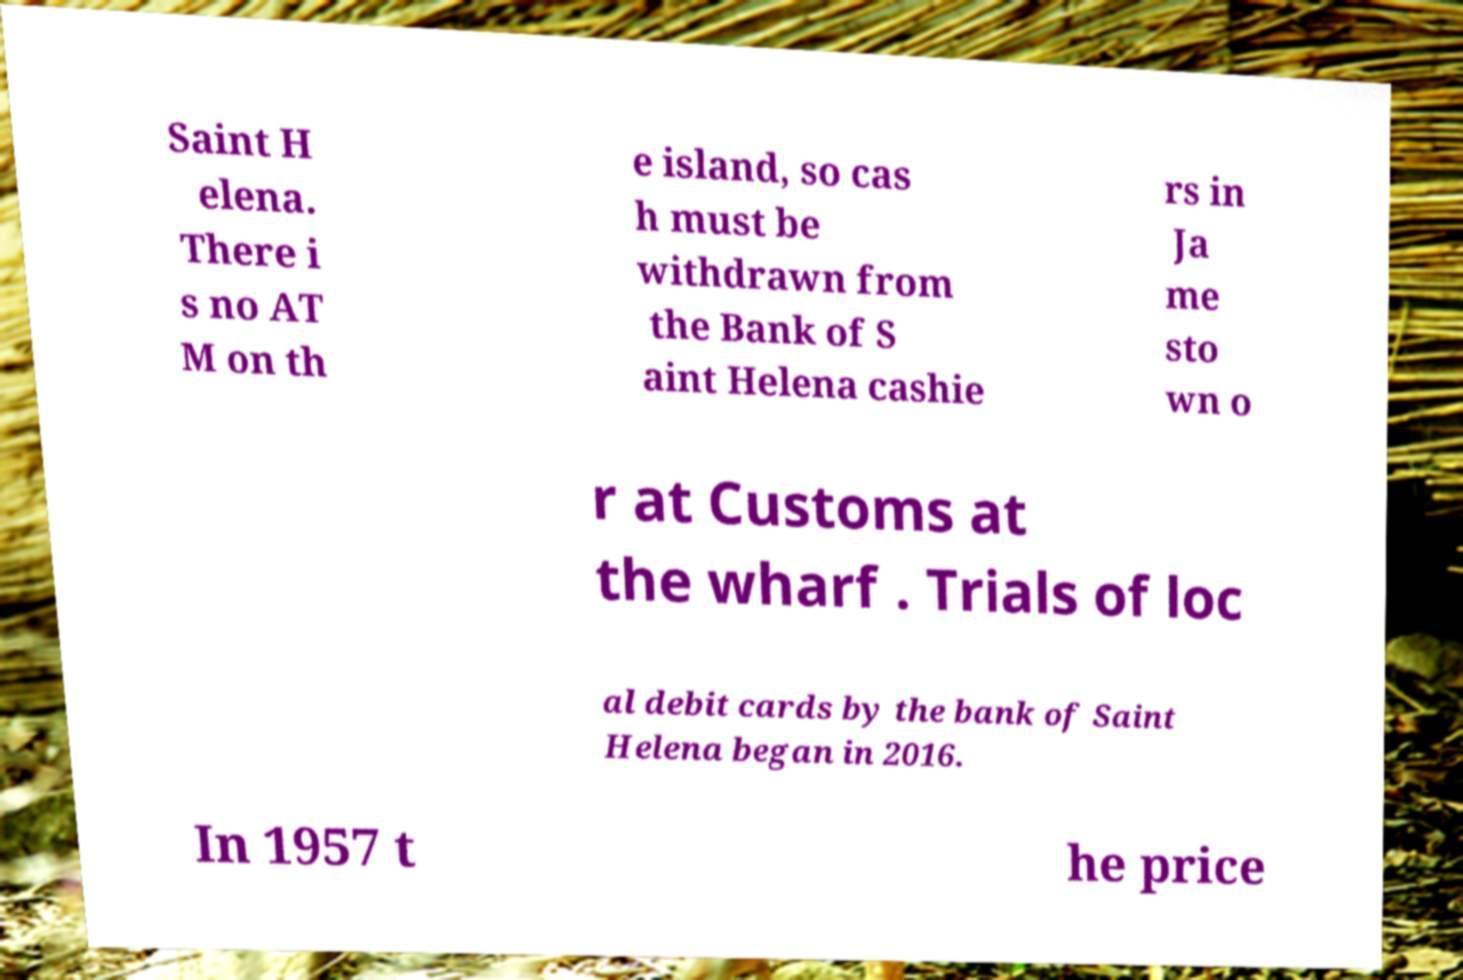Could you assist in decoding the text presented in this image and type it out clearly? Saint H elena. There i s no AT M on th e island, so cas h must be withdrawn from the Bank of S aint Helena cashie rs in Ja me sto wn o r at Customs at the wharf . Trials of loc al debit cards by the bank of Saint Helena began in 2016. In 1957 t he price 